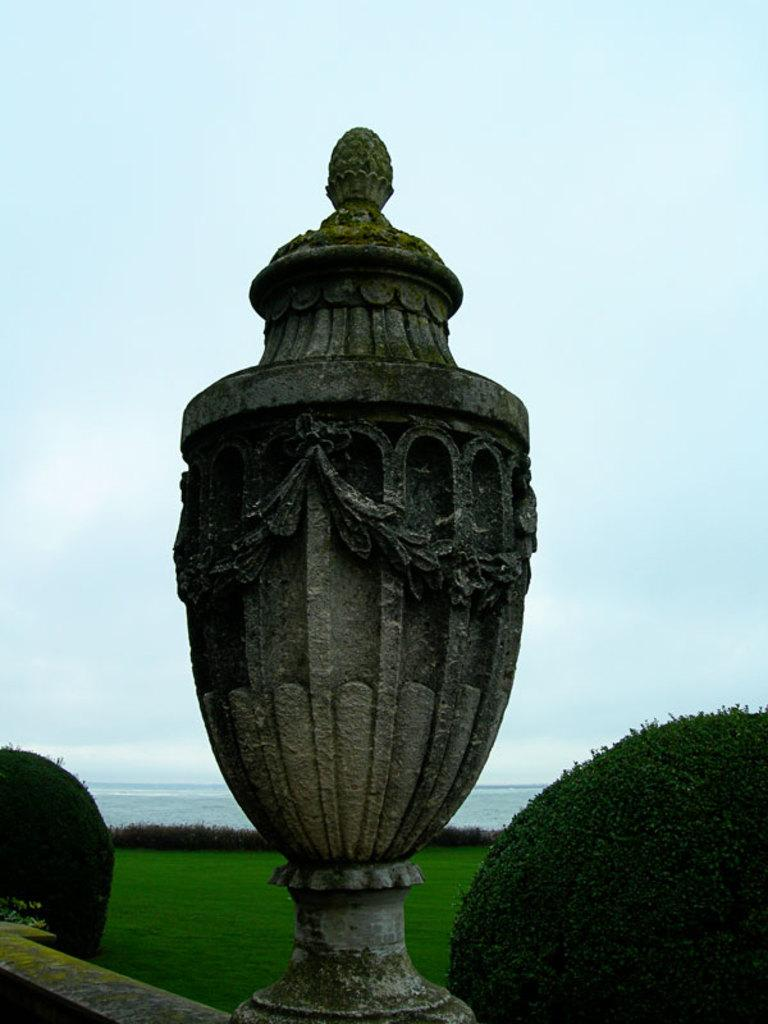What is located in the foreground of the image? There is a fence, a pillar with carvings, and plants in the foreground of the image. What type of vegetation can be seen in the foreground? There are plants visible in the foreground of the image. What can be seen in the background of the image? There is grass, water, and the sky visible in the background of the image. What might be the location of the image based on the background? The image might have been taken near the ocean, given the presence of water and the sky in the background. What type of fuel is being used by the mice in the image? There are no mice present in the image, and therefore no fuel usage can be observed. What is the salt content of the water visible in the background of the image? The salt content of the water cannot be determined from the image, as it does not provide information about the water's composition. 